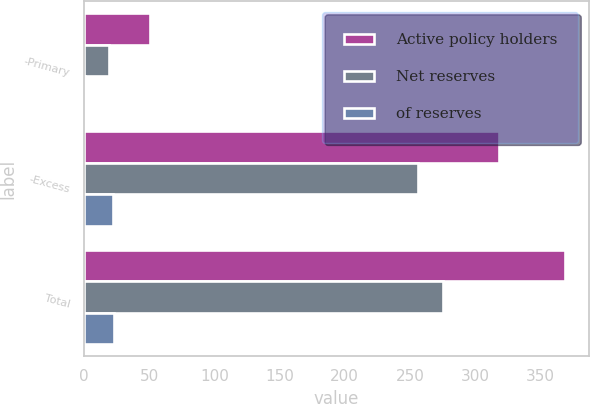Convert chart to OTSL. <chart><loc_0><loc_0><loc_500><loc_500><stacked_bar_chart><ecel><fcel>-Primary<fcel>-Excess<fcel>Total<nl><fcel>Active policy holders<fcel>51<fcel>318<fcel>369<nl><fcel>Net reserves<fcel>19<fcel>256<fcel>275<nl><fcel>of reserves<fcel>1<fcel>22<fcel>23<nl></chart> 